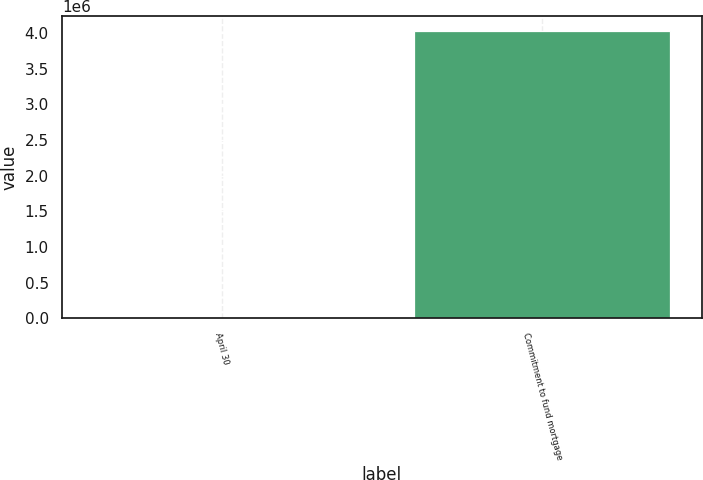<chart> <loc_0><loc_0><loc_500><loc_500><bar_chart><fcel>April 30<fcel>Commitment to fund mortgage<nl><fcel>2006<fcel>4.03204e+06<nl></chart> 